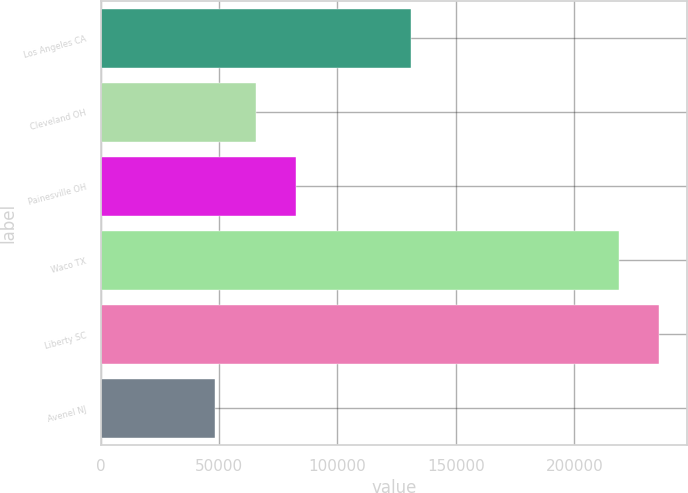<chart> <loc_0><loc_0><loc_500><loc_500><bar_chart><fcel>Los Angeles CA<fcel>Cleveland OH<fcel>Painesville OH<fcel>Waco TX<fcel>Liberty SC<fcel>Avenel NJ<nl><fcel>131000<fcel>65550<fcel>82600<fcel>218800<fcel>235850<fcel>48500<nl></chart> 